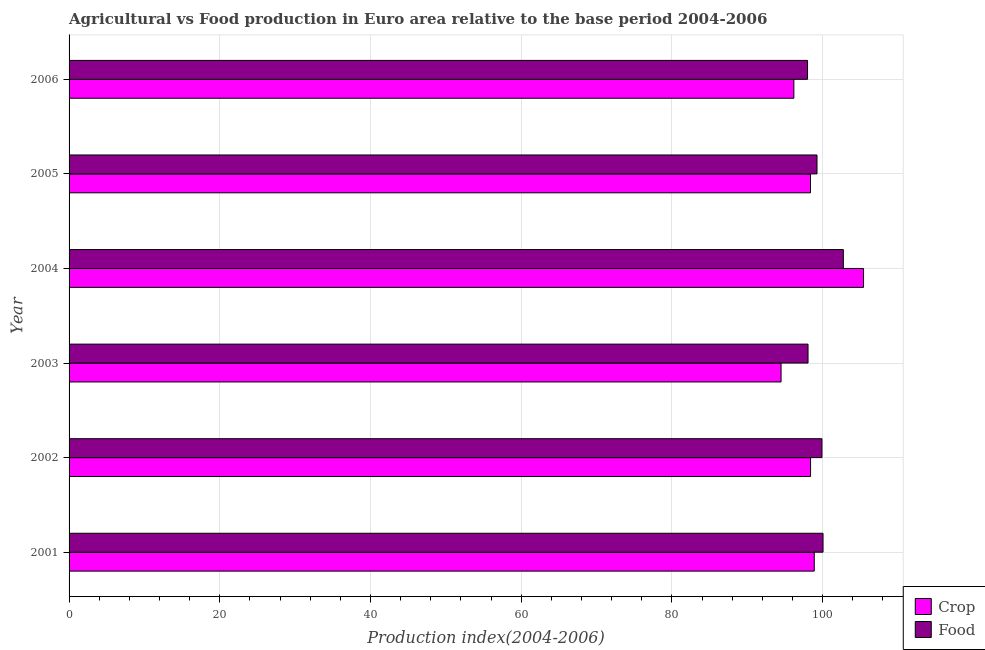How many different coloured bars are there?
Ensure brevity in your answer.  2. How many groups of bars are there?
Your answer should be very brief. 6. Are the number of bars on each tick of the Y-axis equal?
Make the answer very short. Yes. How many bars are there on the 4th tick from the top?
Give a very brief answer. 2. What is the label of the 2nd group of bars from the top?
Make the answer very short. 2005. In how many cases, is the number of bars for a given year not equal to the number of legend labels?
Your answer should be very brief. 0. What is the food production index in 2003?
Offer a very short reply. 98.06. Across all years, what is the maximum crop production index?
Offer a very short reply. 105.43. Across all years, what is the minimum crop production index?
Keep it short and to the point. 94.48. In which year was the food production index maximum?
Offer a very short reply. 2004. What is the total crop production index in the graph?
Provide a short and direct response. 591.77. What is the difference between the crop production index in 2004 and that in 2006?
Offer a terse response. 9.25. What is the difference between the food production index in 2002 and the crop production index in 2001?
Your response must be concise. 1.02. What is the average food production index per year?
Provide a short and direct response. 99.67. In the year 2004, what is the difference between the crop production index and food production index?
Your answer should be compact. 2.68. In how many years, is the crop production index greater than 100 ?
Your response must be concise. 1. What is the ratio of the food production index in 2002 to that in 2004?
Your answer should be very brief. 0.97. Is the food production index in 2003 less than that in 2005?
Offer a very short reply. Yes. What is the difference between the highest and the second highest food production index?
Keep it short and to the point. 2.69. What is the difference between the highest and the lowest food production index?
Offer a terse response. 4.75. Is the sum of the crop production index in 2001 and 2005 greater than the maximum food production index across all years?
Provide a short and direct response. Yes. What does the 1st bar from the top in 2002 represents?
Your answer should be compact. Food. What does the 2nd bar from the bottom in 2004 represents?
Your answer should be compact. Food. Are all the bars in the graph horizontal?
Provide a short and direct response. Yes. What is the difference between two consecutive major ticks on the X-axis?
Offer a very short reply. 20. Are the values on the major ticks of X-axis written in scientific E-notation?
Provide a short and direct response. No. Does the graph contain any zero values?
Provide a short and direct response. No. Does the graph contain grids?
Keep it short and to the point. Yes. Where does the legend appear in the graph?
Provide a succinct answer. Bottom right. How many legend labels are there?
Provide a succinct answer. 2. What is the title of the graph?
Offer a very short reply. Agricultural vs Food production in Euro area relative to the base period 2004-2006. Does "Central government" appear as one of the legend labels in the graph?
Offer a very short reply. No. What is the label or title of the X-axis?
Provide a succinct answer. Production index(2004-2006). What is the Production index(2004-2006) in Crop in 2001?
Give a very brief answer. 98.89. What is the Production index(2004-2006) of Food in 2001?
Keep it short and to the point. 100.05. What is the Production index(2004-2006) of Crop in 2002?
Offer a very short reply. 98.4. What is the Production index(2004-2006) in Food in 2002?
Give a very brief answer. 99.91. What is the Production index(2004-2006) in Crop in 2003?
Your answer should be very brief. 94.48. What is the Production index(2004-2006) of Food in 2003?
Provide a short and direct response. 98.06. What is the Production index(2004-2006) of Crop in 2004?
Keep it short and to the point. 105.43. What is the Production index(2004-2006) in Food in 2004?
Make the answer very short. 102.75. What is the Production index(2004-2006) of Crop in 2005?
Provide a short and direct response. 98.39. What is the Production index(2004-2006) of Food in 2005?
Your answer should be very brief. 99.25. What is the Production index(2004-2006) of Crop in 2006?
Make the answer very short. 96.18. What is the Production index(2004-2006) in Food in 2006?
Provide a short and direct response. 98. Across all years, what is the maximum Production index(2004-2006) in Crop?
Your answer should be very brief. 105.43. Across all years, what is the maximum Production index(2004-2006) of Food?
Your answer should be very brief. 102.75. Across all years, what is the minimum Production index(2004-2006) of Crop?
Ensure brevity in your answer.  94.48. Across all years, what is the minimum Production index(2004-2006) in Food?
Make the answer very short. 98. What is the total Production index(2004-2006) of Crop in the graph?
Your answer should be compact. 591.77. What is the total Production index(2004-2006) of Food in the graph?
Provide a short and direct response. 598.03. What is the difference between the Production index(2004-2006) in Crop in 2001 and that in 2002?
Offer a terse response. 0.49. What is the difference between the Production index(2004-2006) of Food in 2001 and that in 2002?
Ensure brevity in your answer.  0.14. What is the difference between the Production index(2004-2006) in Crop in 2001 and that in 2003?
Your answer should be compact. 4.41. What is the difference between the Production index(2004-2006) in Food in 2001 and that in 2003?
Provide a short and direct response. 1.99. What is the difference between the Production index(2004-2006) in Crop in 2001 and that in 2004?
Offer a very short reply. -6.54. What is the difference between the Production index(2004-2006) in Food in 2001 and that in 2004?
Provide a succinct answer. -2.69. What is the difference between the Production index(2004-2006) of Crop in 2001 and that in 2005?
Provide a short and direct response. 0.5. What is the difference between the Production index(2004-2006) of Food in 2001 and that in 2005?
Offer a very short reply. 0.8. What is the difference between the Production index(2004-2006) of Crop in 2001 and that in 2006?
Keep it short and to the point. 2.71. What is the difference between the Production index(2004-2006) in Food in 2001 and that in 2006?
Your answer should be compact. 2.06. What is the difference between the Production index(2004-2006) of Crop in 2002 and that in 2003?
Give a very brief answer. 3.91. What is the difference between the Production index(2004-2006) in Food in 2002 and that in 2003?
Your answer should be compact. 1.85. What is the difference between the Production index(2004-2006) of Crop in 2002 and that in 2004?
Ensure brevity in your answer.  -7.03. What is the difference between the Production index(2004-2006) in Food in 2002 and that in 2004?
Give a very brief answer. -2.84. What is the difference between the Production index(2004-2006) of Crop in 2002 and that in 2005?
Provide a succinct answer. 0.01. What is the difference between the Production index(2004-2006) in Food in 2002 and that in 2005?
Keep it short and to the point. 0.66. What is the difference between the Production index(2004-2006) in Crop in 2002 and that in 2006?
Give a very brief answer. 2.22. What is the difference between the Production index(2004-2006) of Food in 2002 and that in 2006?
Provide a short and direct response. 1.91. What is the difference between the Production index(2004-2006) of Crop in 2003 and that in 2004?
Provide a succinct answer. -10.94. What is the difference between the Production index(2004-2006) in Food in 2003 and that in 2004?
Your response must be concise. -4.69. What is the difference between the Production index(2004-2006) in Crop in 2003 and that in 2005?
Offer a very short reply. -3.91. What is the difference between the Production index(2004-2006) of Food in 2003 and that in 2005?
Your answer should be compact. -1.19. What is the difference between the Production index(2004-2006) of Crop in 2003 and that in 2006?
Keep it short and to the point. -1.7. What is the difference between the Production index(2004-2006) of Food in 2003 and that in 2006?
Keep it short and to the point. 0.06. What is the difference between the Production index(2004-2006) in Crop in 2004 and that in 2005?
Make the answer very short. 7.04. What is the difference between the Production index(2004-2006) in Food in 2004 and that in 2005?
Your response must be concise. 3.5. What is the difference between the Production index(2004-2006) of Crop in 2004 and that in 2006?
Ensure brevity in your answer.  9.25. What is the difference between the Production index(2004-2006) of Food in 2004 and that in 2006?
Provide a short and direct response. 4.75. What is the difference between the Production index(2004-2006) in Crop in 2005 and that in 2006?
Your response must be concise. 2.21. What is the difference between the Production index(2004-2006) of Food in 2005 and that in 2006?
Ensure brevity in your answer.  1.25. What is the difference between the Production index(2004-2006) in Crop in 2001 and the Production index(2004-2006) in Food in 2002?
Provide a short and direct response. -1.02. What is the difference between the Production index(2004-2006) of Crop in 2001 and the Production index(2004-2006) of Food in 2003?
Your answer should be very brief. 0.83. What is the difference between the Production index(2004-2006) in Crop in 2001 and the Production index(2004-2006) in Food in 2004?
Give a very brief answer. -3.86. What is the difference between the Production index(2004-2006) of Crop in 2001 and the Production index(2004-2006) of Food in 2005?
Ensure brevity in your answer.  -0.36. What is the difference between the Production index(2004-2006) of Crop in 2001 and the Production index(2004-2006) of Food in 2006?
Provide a succinct answer. 0.89. What is the difference between the Production index(2004-2006) in Crop in 2002 and the Production index(2004-2006) in Food in 2003?
Give a very brief answer. 0.34. What is the difference between the Production index(2004-2006) in Crop in 2002 and the Production index(2004-2006) in Food in 2004?
Offer a terse response. -4.35. What is the difference between the Production index(2004-2006) of Crop in 2002 and the Production index(2004-2006) of Food in 2005?
Your answer should be compact. -0.85. What is the difference between the Production index(2004-2006) in Crop in 2002 and the Production index(2004-2006) in Food in 2006?
Make the answer very short. 0.4. What is the difference between the Production index(2004-2006) of Crop in 2003 and the Production index(2004-2006) of Food in 2004?
Provide a succinct answer. -8.27. What is the difference between the Production index(2004-2006) of Crop in 2003 and the Production index(2004-2006) of Food in 2005?
Give a very brief answer. -4.77. What is the difference between the Production index(2004-2006) in Crop in 2003 and the Production index(2004-2006) in Food in 2006?
Provide a short and direct response. -3.51. What is the difference between the Production index(2004-2006) of Crop in 2004 and the Production index(2004-2006) of Food in 2005?
Give a very brief answer. 6.18. What is the difference between the Production index(2004-2006) in Crop in 2004 and the Production index(2004-2006) in Food in 2006?
Make the answer very short. 7.43. What is the difference between the Production index(2004-2006) in Crop in 2005 and the Production index(2004-2006) in Food in 2006?
Provide a short and direct response. 0.39. What is the average Production index(2004-2006) in Crop per year?
Your answer should be very brief. 98.63. What is the average Production index(2004-2006) of Food per year?
Keep it short and to the point. 99.67. In the year 2001, what is the difference between the Production index(2004-2006) in Crop and Production index(2004-2006) in Food?
Offer a very short reply. -1.16. In the year 2002, what is the difference between the Production index(2004-2006) of Crop and Production index(2004-2006) of Food?
Give a very brief answer. -1.51. In the year 2003, what is the difference between the Production index(2004-2006) of Crop and Production index(2004-2006) of Food?
Offer a terse response. -3.58. In the year 2004, what is the difference between the Production index(2004-2006) of Crop and Production index(2004-2006) of Food?
Provide a short and direct response. 2.68. In the year 2005, what is the difference between the Production index(2004-2006) in Crop and Production index(2004-2006) in Food?
Offer a terse response. -0.86. In the year 2006, what is the difference between the Production index(2004-2006) of Crop and Production index(2004-2006) of Food?
Offer a very short reply. -1.82. What is the ratio of the Production index(2004-2006) in Crop in 2001 to that in 2002?
Your answer should be very brief. 1. What is the ratio of the Production index(2004-2006) in Food in 2001 to that in 2002?
Your answer should be very brief. 1. What is the ratio of the Production index(2004-2006) in Crop in 2001 to that in 2003?
Keep it short and to the point. 1.05. What is the ratio of the Production index(2004-2006) in Food in 2001 to that in 2003?
Your answer should be compact. 1.02. What is the ratio of the Production index(2004-2006) of Crop in 2001 to that in 2004?
Provide a succinct answer. 0.94. What is the ratio of the Production index(2004-2006) of Food in 2001 to that in 2004?
Give a very brief answer. 0.97. What is the ratio of the Production index(2004-2006) in Crop in 2001 to that in 2006?
Offer a terse response. 1.03. What is the ratio of the Production index(2004-2006) of Food in 2001 to that in 2006?
Provide a succinct answer. 1.02. What is the ratio of the Production index(2004-2006) of Crop in 2002 to that in 2003?
Your answer should be compact. 1.04. What is the ratio of the Production index(2004-2006) of Food in 2002 to that in 2003?
Offer a very short reply. 1.02. What is the ratio of the Production index(2004-2006) in Food in 2002 to that in 2004?
Your answer should be compact. 0.97. What is the ratio of the Production index(2004-2006) in Crop in 2002 to that in 2005?
Keep it short and to the point. 1. What is the ratio of the Production index(2004-2006) of Food in 2002 to that in 2005?
Offer a terse response. 1.01. What is the ratio of the Production index(2004-2006) in Food in 2002 to that in 2006?
Offer a terse response. 1.02. What is the ratio of the Production index(2004-2006) in Crop in 2003 to that in 2004?
Your response must be concise. 0.9. What is the ratio of the Production index(2004-2006) in Food in 2003 to that in 2004?
Provide a short and direct response. 0.95. What is the ratio of the Production index(2004-2006) of Crop in 2003 to that in 2005?
Provide a succinct answer. 0.96. What is the ratio of the Production index(2004-2006) of Food in 2003 to that in 2005?
Your answer should be very brief. 0.99. What is the ratio of the Production index(2004-2006) of Crop in 2003 to that in 2006?
Your response must be concise. 0.98. What is the ratio of the Production index(2004-2006) of Food in 2003 to that in 2006?
Your response must be concise. 1. What is the ratio of the Production index(2004-2006) of Crop in 2004 to that in 2005?
Offer a very short reply. 1.07. What is the ratio of the Production index(2004-2006) in Food in 2004 to that in 2005?
Keep it short and to the point. 1.04. What is the ratio of the Production index(2004-2006) in Crop in 2004 to that in 2006?
Make the answer very short. 1.1. What is the ratio of the Production index(2004-2006) in Food in 2004 to that in 2006?
Ensure brevity in your answer.  1.05. What is the ratio of the Production index(2004-2006) in Food in 2005 to that in 2006?
Make the answer very short. 1.01. What is the difference between the highest and the second highest Production index(2004-2006) in Crop?
Ensure brevity in your answer.  6.54. What is the difference between the highest and the second highest Production index(2004-2006) of Food?
Give a very brief answer. 2.69. What is the difference between the highest and the lowest Production index(2004-2006) in Crop?
Keep it short and to the point. 10.94. What is the difference between the highest and the lowest Production index(2004-2006) in Food?
Offer a terse response. 4.75. 